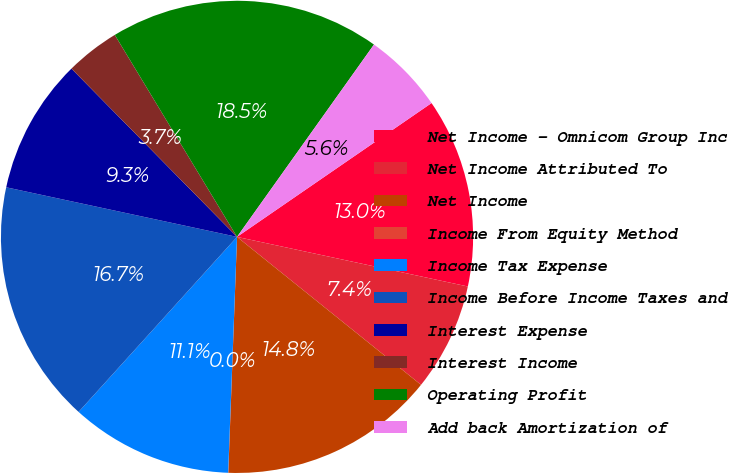Convert chart. <chart><loc_0><loc_0><loc_500><loc_500><pie_chart><fcel>Net Income - Omnicom Group Inc<fcel>Net Income Attributed To<fcel>Net Income<fcel>Income From Equity Method<fcel>Income Tax Expense<fcel>Income Before Income Taxes and<fcel>Interest Expense<fcel>Interest Income<fcel>Operating Profit<fcel>Add back Amortization of<nl><fcel>12.96%<fcel>7.41%<fcel>14.81%<fcel>0.01%<fcel>11.11%<fcel>16.66%<fcel>9.26%<fcel>3.71%<fcel>18.51%<fcel>5.56%<nl></chart> 